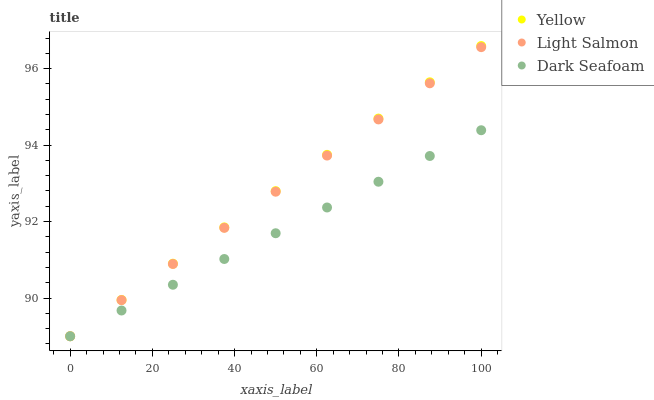Does Dark Seafoam have the minimum area under the curve?
Answer yes or no. Yes. Does Yellow have the maximum area under the curve?
Answer yes or no. Yes. Does Yellow have the minimum area under the curve?
Answer yes or no. No. Does Dark Seafoam have the maximum area under the curve?
Answer yes or no. No. Is Light Salmon the smoothest?
Answer yes or no. Yes. Is Yellow the roughest?
Answer yes or no. Yes. Is Yellow the smoothest?
Answer yes or no. No. Is Dark Seafoam the roughest?
Answer yes or no. No. Does Light Salmon have the lowest value?
Answer yes or no. Yes. Does Yellow have the highest value?
Answer yes or no. Yes. Does Dark Seafoam have the highest value?
Answer yes or no. No. Does Dark Seafoam intersect Yellow?
Answer yes or no. Yes. Is Dark Seafoam less than Yellow?
Answer yes or no. No. Is Dark Seafoam greater than Yellow?
Answer yes or no. No. 